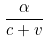Convert formula to latex. <formula><loc_0><loc_0><loc_500><loc_500>\frac { \alpha } { c + v }</formula> 